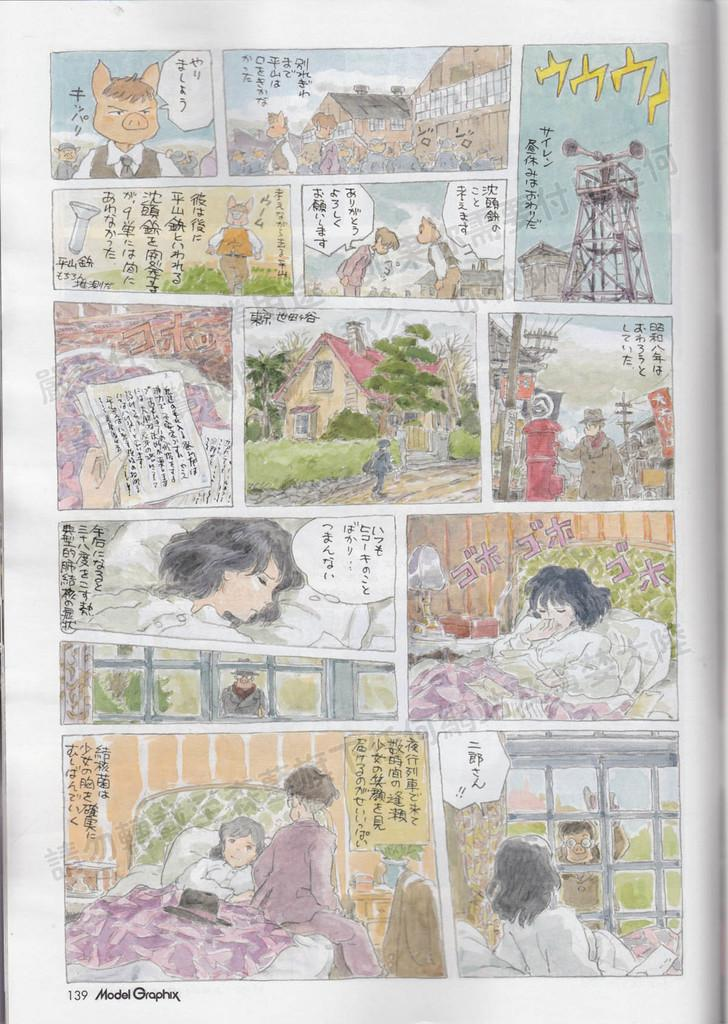What is present in the image that contains both text and images? There is a poster in the image that contains text and images. Can you describe the content of the poster in the image? The poster contains text and images, but the specific content cannot be determined from the provided facts. What type of glass is being used to hold the route in the image? There is no glass or route present in the image; it only contains a poster with text and images. 